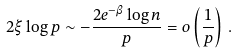Convert formula to latex. <formula><loc_0><loc_0><loc_500><loc_500>2 \xi \log p \sim - \frac { 2 e ^ { - \beta } \log n } { p } = o \left ( \frac { 1 } { p } \right ) \, .</formula> 